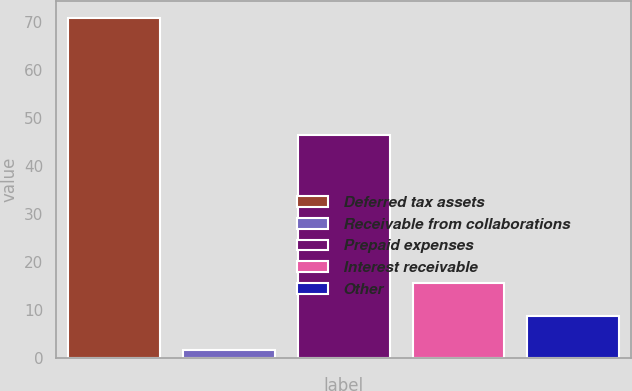Convert chart. <chart><loc_0><loc_0><loc_500><loc_500><bar_chart><fcel>Deferred tax assets<fcel>Receivable from collaborations<fcel>Prepaid expenses<fcel>Interest receivable<fcel>Other<nl><fcel>70.8<fcel>1.7<fcel>46.4<fcel>15.61<fcel>8.7<nl></chart> 